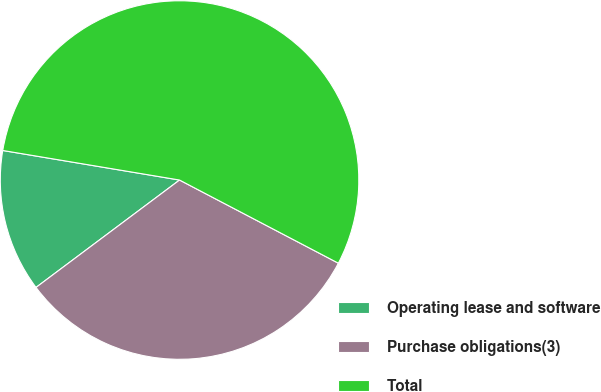Convert chart. <chart><loc_0><loc_0><loc_500><loc_500><pie_chart><fcel>Operating lease and software<fcel>Purchase obligations(3)<fcel>Total<nl><fcel>12.86%<fcel>32.1%<fcel>55.04%<nl></chart> 